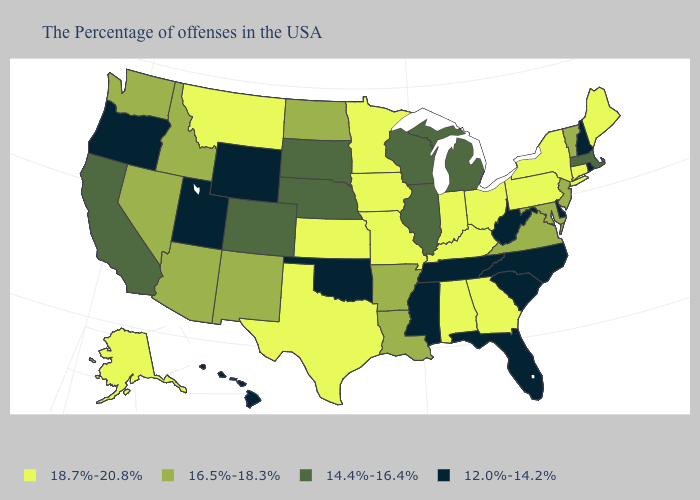Name the states that have a value in the range 14.4%-16.4%?
Short answer required. Massachusetts, Michigan, Wisconsin, Illinois, Nebraska, South Dakota, Colorado, California. Among the states that border New York , which have the lowest value?
Answer briefly. Massachusetts. Name the states that have a value in the range 14.4%-16.4%?
Write a very short answer. Massachusetts, Michigan, Wisconsin, Illinois, Nebraska, South Dakota, Colorado, California. What is the value of Maryland?
Keep it brief. 16.5%-18.3%. Name the states that have a value in the range 16.5%-18.3%?
Quick response, please. Vermont, New Jersey, Maryland, Virginia, Louisiana, Arkansas, North Dakota, New Mexico, Arizona, Idaho, Nevada, Washington. Name the states that have a value in the range 16.5%-18.3%?
Write a very short answer. Vermont, New Jersey, Maryland, Virginia, Louisiana, Arkansas, North Dakota, New Mexico, Arizona, Idaho, Nevada, Washington. What is the lowest value in the Northeast?
Answer briefly. 12.0%-14.2%. What is the value of Michigan?
Quick response, please. 14.4%-16.4%. Name the states that have a value in the range 18.7%-20.8%?
Answer briefly. Maine, Connecticut, New York, Pennsylvania, Ohio, Georgia, Kentucky, Indiana, Alabama, Missouri, Minnesota, Iowa, Kansas, Texas, Montana, Alaska. Among the states that border Virginia , which have the highest value?
Write a very short answer. Kentucky. Among the states that border Massachusetts , which have the highest value?
Short answer required. Connecticut, New York. Which states have the lowest value in the USA?
Quick response, please. Rhode Island, New Hampshire, Delaware, North Carolina, South Carolina, West Virginia, Florida, Tennessee, Mississippi, Oklahoma, Wyoming, Utah, Oregon, Hawaii. What is the value of Oregon?
Short answer required. 12.0%-14.2%. Which states hav the highest value in the South?
Short answer required. Georgia, Kentucky, Alabama, Texas. Name the states that have a value in the range 18.7%-20.8%?
Answer briefly. Maine, Connecticut, New York, Pennsylvania, Ohio, Georgia, Kentucky, Indiana, Alabama, Missouri, Minnesota, Iowa, Kansas, Texas, Montana, Alaska. 